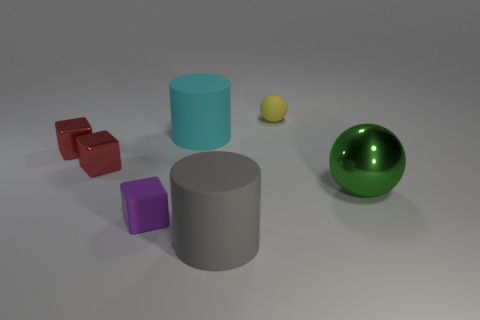Subtract 1 blocks. How many blocks are left? 2 Add 2 large metal balls. How many objects exist? 9 Subtract all cubes. How many objects are left? 4 Subtract all matte cylinders. Subtract all tiny red cubes. How many objects are left? 3 Add 4 large gray things. How many large gray things are left? 5 Add 1 small purple cubes. How many small purple cubes exist? 2 Subtract 1 purple cubes. How many objects are left? 6 